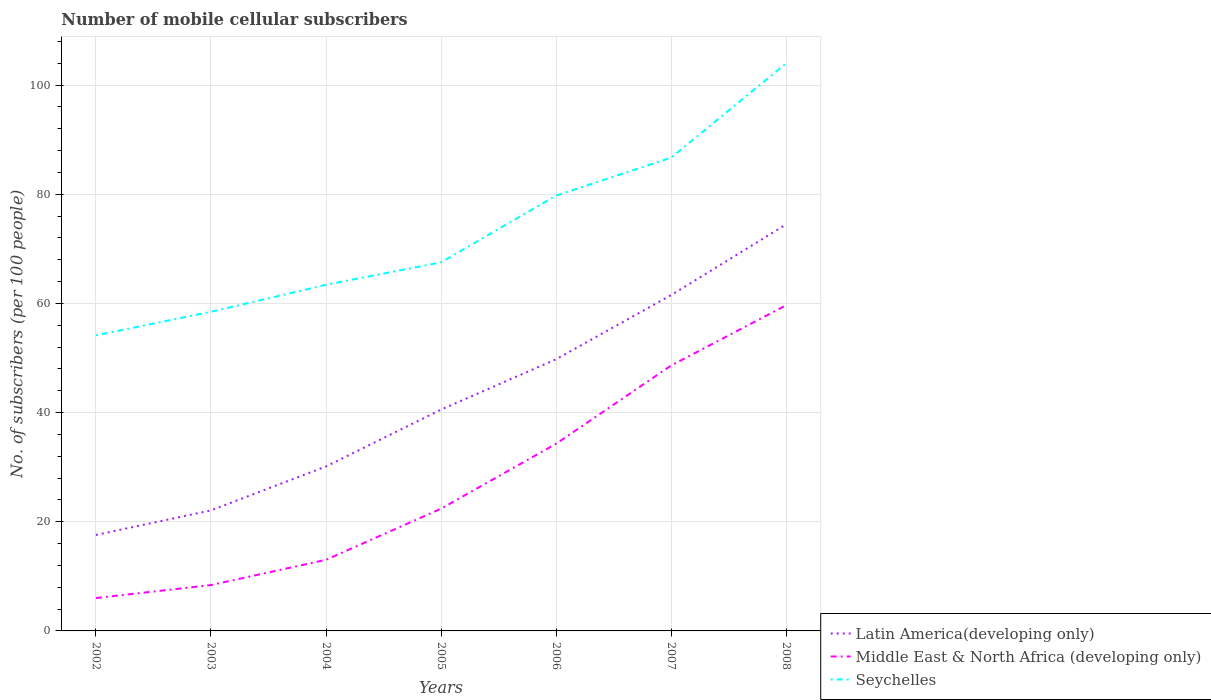Does the line corresponding to Seychelles intersect with the line corresponding to Latin America(developing only)?
Ensure brevity in your answer.  No. Is the number of lines equal to the number of legend labels?
Keep it short and to the point. Yes. Across all years, what is the maximum number of mobile cellular subscribers in Seychelles?
Ensure brevity in your answer.  54.15. What is the total number of mobile cellular subscribers in Middle East & North Africa (developing only) in the graph?
Give a very brief answer. -40.22. What is the difference between the highest and the second highest number of mobile cellular subscribers in Latin America(developing only)?
Offer a terse response. 56.9. Is the number of mobile cellular subscribers in Middle East & North Africa (developing only) strictly greater than the number of mobile cellular subscribers in Latin America(developing only) over the years?
Ensure brevity in your answer.  Yes. What is the difference between two consecutive major ticks on the Y-axis?
Your response must be concise. 20. How many legend labels are there?
Provide a short and direct response. 3. How are the legend labels stacked?
Offer a terse response. Vertical. What is the title of the graph?
Your answer should be very brief. Number of mobile cellular subscribers. Does "Botswana" appear as one of the legend labels in the graph?
Ensure brevity in your answer.  No. What is the label or title of the X-axis?
Give a very brief answer. Years. What is the label or title of the Y-axis?
Ensure brevity in your answer.  No. of subscribers (per 100 people). What is the No. of subscribers (per 100 people) in Latin America(developing only) in 2002?
Offer a terse response. 17.57. What is the No. of subscribers (per 100 people) of Middle East & North Africa (developing only) in 2002?
Your answer should be compact. 6.02. What is the No. of subscribers (per 100 people) in Seychelles in 2002?
Provide a short and direct response. 54.15. What is the No. of subscribers (per 100 people) of Latin America(developing only) in 2003?
Keep it short and to the point. 22.08. What is the No. of subscribers (per 100 people) of Middle East & North Africa (developing only) in 2003?
Ensure brevity in your answer.  8.4. What is the No. of subscribers (per 100 people) in Seychelles in 2003?
Your response must be concise. 58.45. What is the No. of subscribers (per 100 people) of Latin America(developing only) in 2004?
Keep it short and to the point. 30.13. What is the No. of subscribers (per 100 people) of Middle East & North Africa (developing only) in 2004?
Ensure brevity in your answer.  13.03. What is the No. of subscribers (per 100 people) in Seychelles in 2004?
Your response must be concise. 63.4. What is the No. of subscribers (per 100 people) of Latin America(developing only) in 2005?
Ensure brevity in your answer.  40.54. What is the No. of subscribers (per 100 people) in Middle East & North Africa (developing only) in 2005?
Your response must be concise. 22.39. What is the No. of subscribers (per 100 people) of Seychelles in 2005?
Make the answer very short. 67.52. What is the No. of subscribers (per 100 people) of Latin America(developing only) in 2006?
Your answer should be compact. 49.77. What is the No. of subscribers (per 100 people) in Middle East & North Africa (developing only) in 2006?
Offer a terse response. 34.28. What is the No. of subscribers (per 100 people) in Seychelles in 2006?
Your response must be concise. 79.74. What is the No. of subscribers (per 100 people) of Latin America(developing only) in 2007?
Provide a succinct answer. 61.52. What is the No. of subscribers (per 100 people) in Middle East & North Africa (developing only) in 2007?
Ensure brevity in your answer.  48.62. What is the No. of subscribers (per 100 people) in Seychelles in 2007?
Your response must be concise. 86.7. What is the No. of subscribers (per 100 people) of Latin America(developing only) in 2008?
Give a very brief answer. 74.47. What is the No. of subscribers (per 100 people) of Middle East & North Africa (developing only) in 2008?
Offer a terse response. 59.66. What is the No. of subscribers (per 100 people) in Seychelles in 2008?
Your answer should be compact. 103.98. Across all years, what is the maximum No. of subscribers (per 100 people) in Latin America(developing only)?
Make the answer very short. 74.47. Across all years, what is the maximum No. of subscribers (per 100 people) of Middle East & North Africa (developing only)?
Ensure brevity in your answer.  59.66. Across all years, what is the maximum No. of subscribers (per 100 people) in Seychelles?
Offer a very short reply. 103.98. Across all years, what is the minimum No. of subscribers (per 100 people) in Latin America(developing only)?
Offer a terse response. 17.57. Across all years, what is the minimum No. of subscribers (per 100 people) in Middle East & North Africa (developing only)?
Make the answer very short. 6.02. Across all years, what is the minimum No. of subscribers (per 100 people) of Seychelles?
Keep it short and to the point. 54.15. What is the total No. of subscribers (per 100 people) in Latin America(developing only) in the graph?
Offer a very short reply. 296.08. What is the total No. of subscribers (per 100 people) in Middle East & North Africa (developing only) in the graph?
Your answer should be very brief. 192.41. What is the total No. of subscribers (per 100 people) of Seychelles in the graph?
Offer a terse response. 513.94. What is the difference between the No. of subscribers (per 100 people) of Latin America(developing only) in 2002 and that in 2003?
Give a very brief answer. -4.51. What is the difference between the No. of subscribers (per 100 people) of Middle East & North Africa (developing only) in 2002 and that in 2003?
Provide a succinct answer. -2.38. What is the difference between the No. of subscribers (per 100 people) of Seychelles in 2002 and that in 2003?
Make the answer very short. -4.31. What is the difference between the No. of subscribers (per 100 people) in Latin America(developing only) in 2002 and that in 2004?
Keep it short and to the point. -12.55. What is the difference between the No. of subscribers (per 100 people) of Middle East & North Africa (developing only) in 2002 and that in 2004?
Give a very brief answer. -7.01. What is the difference between the No. of subscribers (per 100 people) of Seychelles in 2002 and that in 2004?
Give a very brief answer. -9.26. What is the difference between the No. of subscribers (per 100 people) of Latin America(developing only) in 2002 and that in 2005?
Give a very brief answer. -22.97. What is the difference between the No. of subscribers (per 100 people) of Middle East & North Africa (developing only) in 2002 and that in 2005?
Your response must be concise. -16.37. What is the difference between the No. of subscribers (per 100 people) in Seychelles in 2002 and that in 2005?
Your response must be concise. -13.37. What is the difference between the No. of subscribers (per 100 people) in Latin America(developing only) in 2002 and that in 2006?
Provide a succinct answer. -32.19. What is the difference between the No. of subscribers (per 100 people) of Middle East & North Africa (developing only) in 2002 and that in 2006?
Your answer should be very brief. -28.26. What is the difference between the No. of subscribers (per 100 people) in Seychelles in 2002 and that in 2006?
Offer a terse response. -25.59. What is the difference between the No. of subscribers (per 100 people) of Latin America(developing only) in 2002 and that in 2007?
Ensure brevity in your answer.  -43.94. What is the difference between the No. of subscribers (per 100 people) in Middle East & North Africa (developing only) in 2002 and that in 2007?
Provide a succinct answer. -42.6. What is the difference between the No. of subscribers (per 100 people) in Seychelles in 2002 and that in 2007?
Keep it short and to the point. -32.55. What is the difference between the No. of subscribers (per 100 people) of Latin America(developing only) in 2002 and that in 2008?
Offer a terse response. -56.9. What is the difference between the No. of subscribers (per 100 people) in Middle East & North Africa (developing only) in 2002 and that in 2008?
Give a very brief answer. -53.64. What is the difference between the No. of subscribers (per 100 people) of Seychelles in 2002 and that in 2008?
Your answer should be compact. -49.83. What is the difference between the No. of subscribers (per 100 people) in Latin America(developing only) in 2003 and that in 2004?
Your response must be concise. -8.04. What is the difference between the No. of subscribers (per 100 people) of Middle East & North Africa (developing only) in 2003 and that in 2004?
Offer a very short reply. -4.63. What is the difference between the No. of subscribers (per 100 people) in Seychelles in 2003 and that in 2004?
Offer a very short reply. -4.95. What is the difference between the No. of subscribers (per 100 people) in Latin America(developing only) in 2003 and that in 2005?
Provide a short and direct response. -18.46. What is the difference between the No. of subscribers (per 100 people) of Middle East & North Africa (developing only) in 2003 and that in 2005?
Offer a terse response. -13.99. What is the difference between the No. of subscribers (per 100 people) in Seychelles in 2003 and that in 2005?
Provide a succinct answer. -9.07. What is the difference between the No. of subscribers (per 100 people) in Latin America(developing only) in 2003 and that in 2006?
Ensure brevity in your answer.  -27.68. What is the difference between the No. of subscribers (per 100 people) in Middle East & North Africa (developing only) in 2003 and that in 2006?
Provide a succinct answer. -25.88. What is the difference between the No. of subscribers (per 100 people) of Seychelles in 2003 and that in 2006?
Offer a terse response. -21.29. What is the difference between the No. of subscribers (per 100 people) in Latin America(developing only) in 2003 and that in 2007?
Offer a terse response. -39.43. What is the difference between the No. of subscribers (per 100 people) of Middle East & North Africa (developing only) in 2003 and that in 2007?
Your answer should be compact. -40.22. What is the difference between the No. of subscribers (per 100 people) of Seychelles in 2003 and that in 2007?
Your answer should be compact. -28.24. What is the difference between the No. of subscribers (per 100 people) in Latin America(developing only) in 2003 and that in 2008?
Offer a terse response. -52.39. What is the difference between the No. of subscribers (per 100 people) of Middle East & North Africa (developing only) in 2003 and that in 2008?
Provide a succinct answer. -51.26. What is the difference between the No. of subscribers (per 100 people) in Seychelles in 2003 and that in 2008?
Your answer should be compact. -45.52. What is the difference between the No. of subscribers (per 100 people) of Latin America(developing only) in 2004 and that in 2005?
Your answer should be very brief. -10.42. What is the difference between the No. of subscribers (per 100 people) in Middle East & North Africa (developing only) in 2004 and that in 2005?
Your response must be concise. -9.36. What is the difference between the No. of subscribers (per 100 people) in Seychelles in 2004 and that in 2005?
Give a very brief answer. -4.12. What is the difference between the No. of subscribers (per 100 people) of Latin America(developing only) in 2004 and that in 2006?
Offer a very short reply. -19.64. What is the difference between the No. of subscribers (per 100 people) in Middle East & North Africa (developing only) in 2004 and that in 2006?
Your response must be concise. -21.25. What is the difference between the No. of subscribers (per 100 people) of Seychelles in 2004 and that in 2006?
Offer a terse response. -16.34. What is the difference between the No. of subscribers (per 100 people) of Latin America(developing only) in 2004 and that in 2007?
Make the answer very short. -31.39. What is the difference between the No. of subscribers (per 100 people) of Middle East & North Africa (developing only) in 2004 and that in 2007?
Give a very brief answer. -35.59. What is the difference between the No. of subscribers (per 100 people) of Seychelles in 2004 and that in 2007?
Your answer should be compact. -23.3. What is the difference between the No. of subscribers (per 100 people) in Latin America(developing only) in 2004 and that in 2008?
Your response must be concise. -44.35. What is the difference between the No. of subscribers (per 100 people) in Middle East & North Africa (developing only) in 2004 and that in 2008?
Provide a short and direct response. -46.63. What is the difference between the No. of subscribers (per 100 people) in Seychelles in 2004 and that in 2008?
Your answer should be compact. -40.57. What is the difference between the No. of subscribers (per 100 people) of Latin America(developing only) in 2005 and that in 2006?
Provide a succinct answer. -9.22. What is the difference between the No. of subscribers (per 100 people) in Middle East & North Africa (developing only) in 2005 and that in 2006?
Ensure brevity in your answer.  -11.89. What is the difference between the No. of subscribers (per 100 people) in Seychelles in 2005 and that in 2006?
Your answer should be very brief. -12.22. What is the difference between the No. of subscribers (per 100 people) of Latin America(developing only) in 2005 and that in 2007?
Offer a terse response. -20.97. What is the difference between the No. of subscribers (per 100 people) of Middle East & North Africa (developing only) in 2005 and that in 2007?
Keep it short and to the point. -26.23. What is the difference between the No. of subscribers (per 100 people) of Seychelles in 2005 and that in 2007?
Your response must be concise. -19.18. What is the difference between the No. of subscribers (per 100 people) in Latin America(developing only) in 2005 and that in 2008?
Your answer should be very brief. -33.93. What is the difference between the No. of subscribers (per 100 people) of Middle East & North Africa (developing only) in 2005 and that in 2008?
Give a very brief answer. -37.27. What is the difference between the No. of subscribers (per 100 people) in Seychelles in 2005 and that in 2008?
Ensure brevity in your answer.  -36.46. What is the difference between the No. of subscribers (per 100 people) in Latin America(developing only) in 2006 and that in 2007?
Provide a succinct answer. -11.75. What is the difference between the No. of subscribers (per 100 people) in Middle East & North Africa (developing only) in 2006 and that in 2007?
Make the answer very short. -14.34. What is the difference between the No. of subscribers (per 100 people) of Seychelles in 2006 and that in 2007?
Your response must be concise. -6.96. What is the difference between the No. of subscribers (per 100 people) in Latin America(developing only) in 2006 and that in 2008?
Provide a short and direct response. -24.71. What is the difference between the No. of subscribers (per 100 people) in Middle East & North Africa (developing only) in 2006 and that in 2008?
Give a very brief answer. -25.38. What is the difference between the No. of subscribers (per 100 people) in Seychelles in 2006 and that in 2008?
Offer a terse response. -24.23. What is the difference between the No. of subscribers (per 100 people) in Latin America(developing only) in 2007 and that in 2008?
Your response must be concise. -12.95. What is the difference between the No. of subscribers (per 100 people) in Middle East & North Africa (developing only) in 2007 and that in 2008?
Provide a succinct answer. -11.04. What is the difference between the No. of subscribers (per 100 people) in Seychelles in 2007 and that in 2008?
Your response must be concise. -17.28. What is the difference between the No. of subscribers (per 100 people) of Latin America(developing only) in 2002 and the No. of subscribers (per 100 people) of Middle East & North Africa (developing only) in 2003?
Your answer should be very brief. 9.17. What is the difference between the No. of subscribers (per 100 people) of Latin America(developing only) in 2002 and the No. of subscribers (per 100 people) of Seychelles in 2003?
Provide a succinct answer. -40.88. What is the difference between the No. of subscribers (per 100 people) of Middle East & North Africa (developing only) in 2002 and the No. of subscribers (per 100 people) of Seychelles in 2003?
Your answer should be very brief. -52.43. What is the difference between the No. of subscribers (per 100 people) in Latin America(developing only) in 2002 and the No. of subscribers (per 100 people) in Middle East & North Africa (developing only) in 2004?
Offer a terse response. 4.54. What is the difference between the No. of subscribers (per 100 people) in Latin America(developing only) in 2002 and the No. of subscribers (per 100 people) in Seychelles in 2004?
Keep it short and to the point. -45.83. What is the difference between the No. of subscribers (per 100 people) of Middle East & North Africa (developing only) in 2002 and the No. of subscribers (per 100 people) of Seychelles in 2004?
Keep it short and to the point. -57.38. What is the difference between the No. of subscribers (per 100 people) of Latin America(developing only) in 2002 and the No. of subscribers (per 100 people) of Middle East & North Africa (developing only) in 2005?
Your answer should be very brief. -4.82. What is the difference between the No. of subscribers (per 100 people) in Latin America(developing only) in 2002 and the No. of subscribers (per 100 people) in Seychelles in 2005?
Provide a short and direct response. -49.95. What is the difference between the No. of subscribers (per 100 people) in Middle East & North Africa (developing only) in 2002 and the No. of subscribers (per 100 people) in Seychelles in 2005?
Offer a terse response. -61.5. What is the difference between the No. of subscribers (per 100 people) of Latin America(developing only) in 2002 and the No. of subscribers (per 100 people) of Middle East & North Africa (developing only) in 2006?
Your answer should be compact. -16.71. What is the difference between the No. of subscribers (per 100 people) in Latin America(developing only) in 2002 and the No. of subscribers (per 100 people) in Seychelles in 2006?
Make the answer very short. -62.17. What is the difference between the No. of subscribers (per 100 people) in Middle East & North Africa (developing only) in 2002 and the No. of subscribers (per 100 people) in Seychelles in 2006?
Your answer should be very brief. -73.72. What is the difference between the No. of subscribers (per 100 people) in Latin America(developing only) in 2002 and the No. of subscribers (per 100 people) in Middle East & North Africa (developing only) in 2007?
Your answer should be compact. -31.04. What is the difference between the No. of subscribers (per 100 people) in Latin America(developing only) in 2002 and the No. of subscribers (per 100 people) in Seychelles in 2007?
Your answer should be compact. -69.12. What is the difference between the No. of subscribers (per 100 people) in Middle East & North Africa (developing only) in 2002 and the No. of subscribers (per 100 people) in Seychelles in 2007?
Provide a short and direct response. -80.68. What is the difference between the No. of subscribers (per 100 people) of Latin America(developing only) in 2002 and the No. of subscribers (per 100 people) of Middle East & North Africa (developing only) in 2008?
Make the answer very short. -42.09. What is the difference between the No. of subscribers (per 100 people) of Latin America(developing only) in 2002 and the No. of subscribers (per 100 people) of Seychelles in 2008?
Offer a terse response. -86.4. What is the difference between the No. of subscribers (per 100 people) of Middle East & North Africa (developing only) in 2002 and the No. of subscribers (per 100 people) of Seychelles in 2008?
Your answer should be very brief. -97.96. What is the difference between the No. of subscribers (per 100 people) of Latin America(developing only) in 2003 and the No. of subscribers (per 100 people) of Middle East & North Africa (developing only) in 2004?
Your answer should be compact. 9.05. What is the difference between the No. of subscribers (per 100 people) of Latin America(developing only) in 2003 and the No. of subscribers (per 100 people) of Seychelles in 2004?
Your answer should be compact. -41.32. What is the difference between the No. of subscribers (per 100 people) of Middle East & North Africa (developing only) in 2003 and the No. of subscribers (per 100 people) of Seychelles in 2004?
Make the answer very short. -55. What is the difference between the No. of subscribers (per 100 people) of Latin America(developing only) in 2003 and the No. of subscribers (per 100 people) of Middle East & North Africa (developing only) in 2005?
Give a very brief answer. -0.31. What is the difference between the No. of subscribers (per 100 people) in Latin America(developing only) in 2003 and the No. of subscribers (per 100 people) in Seychelles in 2005?
Your answer should be very brief. -45.44. What is the difference between the No. of subscribers (per 100 people) of Middle East & North Africa (developing only) in 2003 and the No. of subscribers (per 100 people) of Seychelles in 2005?
Make the answer very short. -59.12. What is the difference between the No. of subscribers (per 100 people) of Latin America(developing only) in 2003 and the No. of subscribers (per 100 people) of Middle East & North Africa (developing only) in 2006?
Make the answer very short. -12.2. What is the difference between the No. of subscribers (per 100 people) in Latin America(developing only) in 2003 and the No. of subscribers (per 100 people) in Seychelles in 2006?
Your answer should be compact. -57.66. What is the difference between the No. of subscribers (per 100 people) of Middle East & North Africa (developing only) in 2003 and the No. of subscribers (per 100 people) of Seychelles in 2006?
Your answer should be compact. -71.34. What is the difference between the No. of subscribers (per 100 people) of Latin America(developing only) in 2003 and the No. of subscribers (per 100 people) of Middle East & North Africa (developing only) in 2007?
Give a very brief answer. -26.54. What is the difference between the No. of subscribers (per 100 people) of Latin America(developing only) in 2003 and the No. of subscribers (per 100 people) of Seychelles in 2007?
Your response must be concise. -64.62. What is the difference between the No. of subscribers (per 100 people) of Middle East & North Africa (developing only) in 2003 and the No. of subscribers (per 100 people) of Seychelles in 2007?
Offer a very short reply. -78.3. What is the difference between the No. of subscribers (per 100 people) in Latin America(developing only) in 2003 and the No. of subscribers (per 100 people) in Middle East & North Africa (developing only) in 2008?
Offer a terse response. -37.58. What is the difference between the No. of subscribers (per 100 people) of Latin America(developing only) in 2003 and the No. of subscribers (per 100 people) of Seychelles in 2008?
Provide a short and direct response. -81.89. What is the difference between the No. of subscribers (per 100 people) in Middle East & North Africa (developing only) in 2003 and the No. of subscribers (per 100 people) in Seychelles in 2008?
Ensure brevity in your answer.  -95.58. What is the difference between the No. of subscribers (per 100 people) in Latin America(developing only) in 2004 and the No. of subscribers (per 100 people) in Middle East & North Africa (developing only) in 2005?
Ensure brevity in your answer.  7.73. What is the difference between the No. of subscribers (per 100 people) in Latin America(developing only) in 2004 and the No. of subscribers (per 100 people) in Seychelles in 2005?
Offer a very short reply. -37.39. What is the difference between the No. of subscribers (per 100 people) in Middle East & North Africa (developing only) in 2004 and the No. of subscribers (per 100 people) in Seychelles in 2005?
Your answer should be compact. -54.49. What is the difference between the No. of subscribers (per 100 people) of Latin America(developing only) in 2004 and the No. of subscribers (per 100 people) of Middle East & North Africa (developing only) in 2006?
Your response must be concise. -4.16. What is the difference between the No. of subscribers (per 100 people) of Latin America(developing only) in 2004 and the No. of subscribers (per 100 people) of Seychelles in 2006?
Provide a short and direct response. -49.62. What is the difference between the No. of subscribers (per 100 people) in Middle East & North Africa (developing only) in 2004 and the No. of subscribers (per 100 people) in Seychelles in 2006?
Give a very brief answer. -66.71. What is the difference between the No. of subscribers (per 100 people) in Latin America(developing only) in 2004 and the No. of subscribers (per 100 people) in Middle East & North Africa (developing only) in 2007?
Give a very brief answer. -18.49. What is the difference between the No. of subscribers (per 100 people) in Latin America(developing only) in 2004 and the No. of subscribers (per 100 people) in Seychelles in 2007?
Your answer should be compact. -56.57. What is the difference between the No. of subscribers (per 100 people) in Middle East & North Africa (developing only) in 2004 and the No. of subscribers (per 100 people) in Seychelles in 2007?
Keep it short and to the point. -73.67. What is the difference between the No. of subscribers (per 100 people) in Latin America(developing only) in 2004 and the No. of subscribers (per 100 people) in Middle East & North Africa (developing only) in 2008?
Offer a very short reply. -29.54. What is the difference between the No. of subscribers (per 100 people) in Latin America(developing only) in 2004 and the No. of subscribers (per 100 people) in Seychelles in 2008?
Your answer should be very brief. -73.85. What is the difference between the No. of subscribers (per 100 people) of Middle East & North Africa (developing only) in 2004 and the No. of subscribers (per 100 people) of Seychelles in 2008?
Provide a short and direct response. -90.95. What is the difference between the No. of subscribers (per 100 people) in Latin America(developing only) in 2005 and the No. of subscribers (per 100 people) in Middle East & North Africa (developing only) in 2006?
Your response must be concise. 6.26. What is the difference between the No. of subscribers (per 100 people) of Latin America(developing only) in 2005 and the No. of subscribers (per 100 people) of Seychelles in 2006?
Keep it short and to the point. -39.2. What is the difference between the No. of subscribers (per 100 people) in Middle East & North Africa (developing only) in 2005 and the No. of subscribers (per 100 people) in Seychelles in 2006?
Make the answer very short. -57.35. What is the difference between the No. of subscribers (per 100 people) of Latin America(developing only) in 2005 and the No. of subscribers (per 100 people) of Middle East & North Africa (developing only) in 2007?
Provide a short and direct response. -8.07. What is the difference between the No. of subscribers (per 100 people) of Latin America(developing only) in 2005 and the No. of subscribers (per 100 people) of Seychelles in 2007?
Provide a short and direct response. -46.15. What is the difference between the No. of subscribers (per 100 people) of Middle East & North Africa (developing only) in 2005 and the No. of subscribers (per 100 people) of Seychelles in 2007?
Give a very brief answer. -64.31. What is the difference between the No. of subscribers (per 100 people) in Latin America(developing only) in 2005 and the No. of subscribers (per 100 people) in Middle East & North Africa (developing only) in 2008?
Your answer should be compact. -19.12. What is the difference between the No. of subscribers (per 100 people) of Latin America(developing only) in 2005 and the No. of subscribers (per 100 people) of Seychelles in 2008?
Provide a succinct answer. -63.43. What is the difference between the No. of subscribers (per 100 people) of Middle East & North Africa (developing only) in 2005 and the No. of subscribers (per 100 people) of Seychelles in 2008?
Your answer should be very brief. -81.58. What is the difference between the No. of subscribers (per 100 people) in Latin America(developing only) in 2006 and the No. of subscribers (per 100 people) in Middle East & North Africa (developing only) in 2007?
Your response must be concise. 1.15. What is the difference between the No. of subscribers (per 100 people) of Latin America(developing only) in 2006 and the No. of subscribers (per 100 people) of Seychelles in 2007?
Offer a terse response. -36.93. What is the difference between the No. of subscribers (per 100 people) in Middle East & North Africa (developing only) in 2006 and the No. of subscribers (per 100 people) in Seychelles in 2007?
Ensure brevity in your answer.  -52.42. What is the difference between the No. of subscribers (per 100 people) in Latin America(developing only) in 2006 and the No. of subscribers (per 100 people) in Middle East & North Africa (developing only) in 2008?
Make the answer very short. -9.9. What is the difference between the No. of subscribers (per 100 people) of Latin America(developing only) in 2006 and the No. of subscribers (per 100 people) of Seychelles in 2008?
Offer a very short reply. -54.21. What is the difference between the No. of subscribers (per 100 people) of Middle East & North Africa (developing only) in 2006 and the No. of subscribers (per 100 people) of Seychelles in 2008?
Offer a terse response. -69.69. What is the difference between the No. of subscribers (per 100 people) of Latin America(developing only) in 2007 and the No. of subscribers (per 100 people) of Middle East & North Africa (developing only) in 2008?
Provide a short and direct response. 1.85. What is the difference between the No. of subscribers (per 100 people) of Latin America(developing only) in 2007 and the No. of subscribers (per 100 people) of Seychelles in 2008?
Your answer should be compact. -42.46. What is the difference between the No. of subscribers (per 100 people) of Middle East & North Africa (developing only) in 2007 and the No. of subscribers (per 100 people) of Seychelles in 2008?
Offer a very short reply. -55.36. What is the average No. of subscribers (per 100 people) of Latin America(developing only) per year?
Ensure brevity in your answer.  42.3. What is the average No. of subscribers (per 100 people) of Middle East & North Africa (developing only) per year?
Your response must be concise. 27.49. What is the average No. of subscribers (per 100 people) of Seychelles per year?
Provide a short and direct response. 73.42. In the year 2002, what is the difference between the No. of subscribers (per 100 people) in Latin America(developing only) and No. of subscribers (per 100 people) in Middle East & North Africa (developing only)?
Keep it short and to the point. 11.55. In the year 2002, what is the difference between the No. of subscribers (per 100 people) of Latin America(developing only) and No. of subscribers (per 100 people) of Seychelles?
Provide a short and direct response. -36.57. In the year 2002, what is the difference between the No. of subscribers (per 100 people) in Middle East & North Africa (developing only) and No. of subscribers (per 100 people) in Seychelles?
Your answer should be compact. -48.13. In the year 2003, what is the difference between the No. of subscribers (per 100 people) in Latin America(developing only) and No. of subscribers (per 100 people) in Middle East & North Africa (developing only)?
Your response must be concise. 13.68. In the year 2003, what is the difference between the No. of subscribers (per 100 people) in Latin America(developing only) and No. of subscribers (per 100 people) in Seychelles?
Offer a very short reply. -36.37. In the year 2003, what is the difference between the No. of subscribers (per 100 people) of Middle East & North Africa (developing only) and No. of subscribers (per 100 people) of Seychelles?
Your response must be concise. -50.05. In the year 2004, what is the difference between the No. of subscribers (per 100 people) in Latin America(developing only) and No. of subscribers (per 100 people) in Middle East & North Africa (developing only)?
Your answer should be very brief. 17.1. In the year 2004, what is the difference between the No. of subscribers (per 100 people) in Latin America(developing only) and No. of subscribers (per 100 people) in Seychelles?
Keep it short and to the point. -33.28. In the year 2004, what is the difference between the No. of subscribers (per 100 people) of Middle East & North Africa (developing only) and No. of subscribers (per 100 people) of Seychelles?
Provide a succinct answer. -50.37. In the year 2005, what is the difference between the No. of subscribers (per 100 people) of Latin America(developing only) and No. of subscribers (per 100 people) of Middle East & North Africa (developing only)?
Offer a very short reply. 18.15. In the year 2005, what is the difference between the No. of subscribers (per 100 people) of Latin America(developing only) and No. of subscribers (per 100 people) of Seychelles?
Ensure brevity in your answer.  -26.98. In the year 2005, what is the difference between the No. of subscribers (per 100 people) of Middle East & North Africa (developing only) and No. of subscribers (per 100 people) of Seychelles?
Your response must be concise. -45.13. In the year 2006, what is the difference between the No. of subscribers (per 100 people) of Latin America(developing only) and No. of subscribers (per 100 people) of Middle East & North Africa (developing only)?
Your response must be concise. 15.48. In the year 2006, what is the difference between the No. of subscribers (per 100 people) in Latin America(developing only) and No. of subscribers (per 100 people) in Seychelles?
Ensure brevity in your answer.  -29.98. In the year 2006, what is the difference between the No. of subscribers (per 100 people) in Middle East & North Africa (developing only) and No. of subscribers (per 100 people) in Seychelles?
Your response must be concise. -45.46. In the year 2007, what is the difference between the No. of subscribers (per 100 people) of Latin America(developing only) and No. of subscribers (per 100 people) of Middle East & North Africa (developing only)?
Give a very brief answer. 12.9. In the year 2007, what is the difference between the No. of subscribers (per 100 people) of Latin America(developing only) and No. of subscribers (per 100 people) of Seychelles?
Offer a terse response. -25.18. In the year 2007, what is the difference between the No. of subscribers (per 100 people) of Middle East & North Africa (developing only) and No. of subscribers (per 100 people) of Seychelles?
Ensure brevity in your answer.  -38.08. In the year 2008, what is the difference between the No. of subscribers (per 100 people) of Latin America(developing only) and No. of subscribers (per 100 people) of Middle East & North Africa (developing only)?
Give a very brief answer. 14.81. In the year 2008, what is the difference between the No. of subscribers (per 100 people) in Latin America(developing only) and No. of subscribers (per 100 people) in Seychelles?
Provide a succinct answer. -29.5. In the year 2008, what is the difference between the No. of subscribers (per 100 people) in Middle East & North Africa (developing only) and No. of subscribers (per 100 people) in Seychelles?
Give a very brief answer. -44.31. What is the ratio of the No. of subscribers (per 100 people) of Latin America(developing only) in 2002 to that in 2003?
Provide a short and direct response. 0.8. What is the ratio of the No. of subscribers (per 100 people) in Middle East & North Africa (developing only) in 2002 to that in 2003?
Provide a short and direct response. 0.72. What is the ratio of the No. of subscribers (per 100 people) in Seychelles in 2002 to that in 2003?
Your answer should be compact. 0.93. What is the ratio of the No. of subscribers (per 100 people) in Latin America(developing only) in 2002 to that in 2004?
Provide a succinct answer. 0.58. What is the ratio of the No. of subscribers (per 100 people) in Middle East & North Africa (developing only) in 2002 to that in 2004?
Offer a very short reply. 0.46. What is the ratio of the No. of subscribers (per 100 people) in Seychelles in 2002 to that in 2004?
Provide a short and direct response. 0.85. What is the ratio of the No. of subscribers (per 100 people) of Latin America(developing only) in 2002 to that in 2005?
Provide a succinct answer. 0.43. What is the ratio of the No. of subscribers (per 100 people) in Middle East & North Africa (developing only) in 2002 to that in 2005?
Keep it short and to the point. 0.27. What is the ratio of the No. of subscribers (per 100 people) in Seychelles in 2002 to that in 2005?
Your answer should be very brief. 0.8. What is the ratio of the No. of subscribers (per 100 people) in Latin America(developing only) in 2002 to that in 2006?
Make the answer very short. 0.35. What is the ratio of the No. of subscribers (per 100 people) of Middle East & North Africa (developing only) in 2002 to that in 2006?
Offer a very short reply. 0.18. What is the ratio of the No. of subscribers (per 100 people) of Seychelles in 2002 to that in 2006?
Keep it short and to the point. 0.68. What is the ratio of the No. of subscribers (per 100 people) of Latin America(developing only) in 2002 to that in 2007?
Make the answer very short. 0.29. What is the ratio of the No. of subscribers (per 100 people) in Middle East & North Africa (developing only) in 2002 to that in 2007?
Provide a succinct answer. 0.12. What is the ratio of the No. of subscribers (per 100 people) of Seychelles in 2002 to that in 2007?
Provide a succinct answer. 0.62. What is the ratio of the No. of subscribers (per 100 people) in Latin America(developing only) in 2002 to that in 2008?
Offer a terse response. 0.24. What is the ratio of the No. of subscribers (per 100 people) of Middle East & North Africa (developing only) in 2002 to that in 2008?
Provide a short and direct response. 0.1. What is the ratio of the No. of subscribers (per 100 people) of Seychelles in 2002 to that in 2008?
Make the answer very short. 0.52. What is the ratio of the No. of subscribers (per 100 people) of Latin America(developing only) in 2003 to that in 2004?
Your response must be concise. 0.73. What is the ratio of the No. of subscribers (per 100 people) in Middle East & North Africa (developing only) in 2003 to that in 2004?
Offer a very short reply. 0.64. What is the ratio of the No. of subscribers (per 100 people) of Seychelles in 2003 to that in 2004?
Give a very brief answer. 0.92. What is the ratio of the No. of subscribers (per 100 people) of Latin America(developing only) in 2003 to that in 2005?
Provide a succinct answer. 0.54. What is the ratio of the No. of subscribers (per 100 people) in Middle East & North Africa (developing only) in 2003 to that in 2005?
Make the answer very short. 0.38. What is the ratio of the No. of subscribers (per 100 people) of Seychelles in 2003 to that in 2005?
Your answer should be very brief. 0.87. What is the ratio of the No. of subscribers (per 100 people) in Latin America(developing only) in 2003 to that in 2006?
Give a very brief answer. 0.44. What is the ratio of the No. of subscribers (per 100 people) of Middle East & North Africa (developing only) in 2003 to that in 2006?
Offer a terse response. 0.24. What is the ratio of the No. of subscribers (per 100 people) in Seychelles in 2003 to that in 2006?
Offer a terse response. 0.73. What is the ratio of the No. of subscribers (per 100 people) in Latin America(developing only) in 2003 to that in 2007?
Provide a succinct answer. 0.36. What is the ratio of the No. of subscribers (per 100 people) of Middle East & North Africa (developing only) in 2003 to that in 2007?
Provide a short and direct response. 0.17. What is the ratio of the No. of subscribers (per 100 people) in Seychelles in 2003 to that in 2007?
Your response must be concise. 0.67. What is the ratio of the No. of subscribers (per 100 people) of Latin America(developing only) in 2003 to that in 2008?
Your answer should be very brief. 0.3. What is the ratio of the No. of subscribers (per 100 people) of Middle East & North Africa (developing only) in 2003 to that in 2008?
Give a very brief answer. 0.14. What is the ratio of the No. of subscribers (per 100 people) in Seychelles in 2003 to that in 2008?
Provide a succinct answer. 0.56. What is the ratio of the No. of subscribers (per 100 people) in Latin America(developing only) in 2004 to that in 2005?
Keep it short and to the point. 0.74. What is the ratio of the No. of subscribers (per 100 people) of Middle East & North Africa (developing only) in 2004 to that in 2005?
Make the answer very short. 0.58. What is the ratio of the No. of subscribers (per 100 people) of Seychelles in 2004 to that in 2005?
Keep it short and to the point. 0.94. What is the ratio of the No. of subscribers (per 100 people) of Latin America(developing only) in 2004 to that in 2006?
Keep it short and to the point. 0.61. What is the ratio of the No. of subscribers (per 100 people) of Middle East & North Africa (developing only) in 2004 to that in 2006?
Offer a very short reply. 0.38. What is the ratio of the No. of subscribers (per 100 people) of Seychelles in 2004 to that in 2006?
Make the answer very short. 0.8. What is the ratio of the No. of subscribers (per 100 people) of Latin America(developing only) in 2004 to that in 2007?
Give a very brief answer. 0.49. What is the ratio of the No. of subscribers (per 100 people) of Middle East & North Africa (developing only) in 2004 to that in 2007?
Provide a short and direct response. 0.27. What is the ratio of the No. of subscribers (per 100 people) in Seychelles in 2004 to that in 2007?
Give a very brief answer. 0.73. What is the ratio of the No. of subscribers (per 100 people) of Latin America(developing only) in 2004 to that in 2008?
Provide a succinct answer. 0.4. What is the ratio of the No. of subscribers (per 100 people) in Middle East & North Africa (developing only) in 2004 to that in 2008?
Provide a short and direct response. 0.22. What is the ratio of the No. of subscribers (per 100 people) of Seychelles in 2004 to that in 2008?
Provide a succinct answer. 0.61. What is the ratio of the No. of subscribers (per 100 people) in Latin America(developing only) in 2005 to that in 2006?
Your answer should be compact. 0.81. What is the ratio of the No. of subscribers (per 100 people) in Middle East & North Africa (developing only) in 2005 to that in 2006?
Offer a terse response. 0.65. What is the ratio of the No. of subscribers (per 100 people) of Seychelles in 2005 to that in 2006?
Your response must be concise. 0.85. What is the ratio of the No. of subscribers (per 100 people) of Latin America(developing only) in 2005 to that in 2007?
Provide a succinct answer. 0.66. What is the ratio of the No. of subscribers (per 100 people) in Middle East & North Africa (developing only) in 2005 to that in 2007?
Your answer should be compact. 0.46. What is the ratio of the No. of subscribers (per 100 people) of Seychelles in 2005 to that in 2007?
Provide a succinct answer. 0.78. What is the ratio of the No. of subscribers (per 100 people) in Latin America(developing only) in 2005 to that in 2008?
Your response must be concise. 0.54. What is the ratio of the No. of subscribers (per 100 people) in Middle East & North Africa (developing only) in 2005 to that in 2008?
Offer a terse response. 0.38. What is the ratio of the No. of subscribers (per 100 people) in Seychelles in 2005 to that in 2008?
Provide a succinct answer. 0.65. What is the ratio of the No. of subscribers (per 100 people) of Latin America(developing only) in 2006 to that in 2007?
Ensure brevity in your answer.  0.81. What is the ratio of the No. of subscribers (per 100 people) of Middle East & North Africa (developing only) in 2006 to that in 2007?
Your answer should be very brief. 0.71. What is the ratio of the No. of subscribers (per 100 people) in Seychelles in 2006 to that in 2007?
Ensure brevity in your answer.  0.92. What is the ratio of the No. of subscribers (per 100 people) of Latin America(developing only) in 2006 to that in 2008?
Provide a short and direct response. 0.67. What is the ratio of the No. of subscribers (per 100 people) of Middle East & North Africa (developing only) in 2006 to that in 2008?
Provide a succinct answer. 0.57. What is the ratio of the No. of subscribers (per 100 people) in Seychelles in 2006 to that in 2008?
Offer a terse response. 0.77. What is the ratio of the No. of subscribers (per 100 people) of Latin America(developing only) in 2007 to that in 2008?
Your answer should be compact. 0.83. What is the ratio of the No. of subscribers (per 100 people) in Middle East & North Africa (developing only) in 2007 to that in 2008?
Your response must be concise. 0.81. What is the ratio of the No. of subscribers (per 100 people) of Seychelles in 2007 to that in 2008?
Keep it short and to the point. 0.83. What is the difference between the highest and the second highest No. of subscribers (per 100 people) of Latin America(developing only)?
Your response must be concise. 12.95. What is the difference between the highest and the second highest No. of subscribers (per 100 people) of Middle East & North Africa (developing only)?
Provide a succinct answer. 11.04. What is the difference between the highest and the second highest No. of subscribers (per 100 people) in Seychelles?
Make the answer very short. 17.28. What is the difference between the highest and the lowest No. of subscribers (per 100 people) of Latin America(developing only)?
Your response must be concise. 56.9. What is the difference between the highest and the lowest No. of subscribers (per 100 people) in Middle East & North Africa (developing only)?
Ensure brevity in your answer.  53.64. What is the difference between the highest and the lowest No. of subscribers (per 100 people) in Seychelles?
Ensure brevity in your answer.  49.83. 